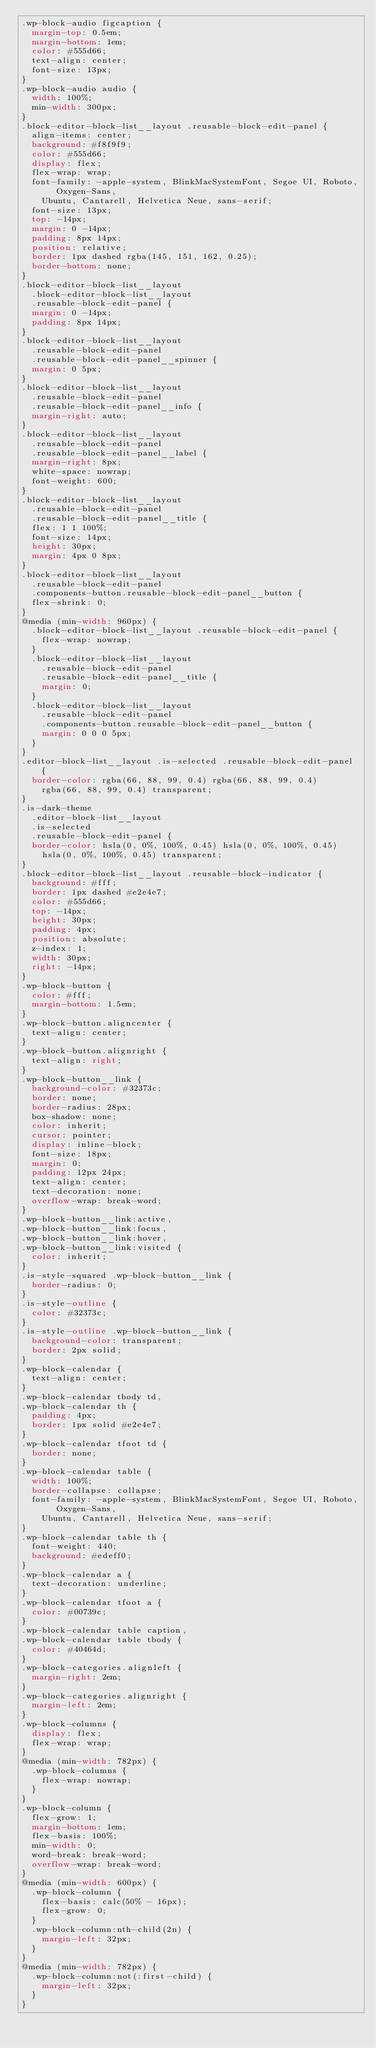Convert code to text. <code><loc_0><loc_0><loc_500><loc_500><_CSS_>.wp-block-audio figcaption {
  margin-top: 0.5em;
  margin-bottom: 1em;
  color: #555d66;
  text-align: center;
  font-size: 13px;
}
.wp-block-audio audio {
  width: 100%;
  min-width: 300px;
}
.block-editor-block-list__layout .reusable-block-edit-panel {
  align-items: center;
  background: #f8f9f9;
  color: #555d66;
  display: flex;
  flex-wrap: wrap;
  font-family: -apple-system, BlinkMacSystemFont, Segoe UI, Roboto, Oxygen-Sans,
    Ubuntu, Cantarell, Helvetica Neue, sans-serif;
  font-size: 13px;
  top: -14px;
  margin: 0 -14px;
  padding: 8px 14px;
  position: relative;
  border: 1px dashed rgba(145, 151, 162, 0.25);
  border-bottom: none;
}
.block-editor-block-list__layout
  .block-editor-block-list__layout
  .reusable-block-edit-panel {
  margin: 0 -14px;
  padding: 8px 14px;
}
.block-editor-block-list__layout
  .reusable-block-edit-panel
  .reusable-block-edit-panel__spinner {
  margin: 0 5px;
}
.block-editor-block-list__layout
  .reusable-block-edit-panel
  .reusable-block-edit-panel__info {
  margin-right: auto;
}
.block-editor-block-list__layout
  .reusable-block-edit-panel
  .reusable-block-edit-panel__label {
  margin-right: 8px;
  white-space: nowrap;
  font-weight: 600;
}
.block-editor-block-list__layout
  .reusable-block-edit-panel
  .reusable-block-edit-panel__title {
  flex: 1 1 100%;
  font-size: 14px;
  height: 30px;
  margin: 4px 0 8px;
}
.block-editor-block-list__layout
  .reusable-block-edit-panel
  .components-button.reusable-block-edit-panel__button {
  flex-shrink: 0;
}
@media (min-width: 960px) {
  .block-editor-block-list__layout .reusable-block-edit-panel {
    flex-wrap: nowrap;
  }
  .block-editor-block-list__layout
    .reusable-block-edit-panel
    .reusable-block-edit-panel__title {
    margin: 0;
  }
  .block-editor-block-list__layout
    .reusable-block-edit-panel
    .components-button.reusable-block-edit-panel__button {
    margin: 0 0 0 5px;
  }
}
.editor-block-list__layout .is-selected .reusable-block-edit-panel {
  border-color: rgba(66, 88, 99, 0.4) rgba(66, 88, 99, 0.4)
    rgba(66, 88, 99, 0.4) transparent;
}
.is-dark-theme
  .editor-block-list__layout
  .is-selected
  .reusable-block-edit-panel {
  border-color: hsla(0, 0%, 100%, 0.45) hsla(0, 0%, 100%, 0.45)
    hsla(0, 0%, 100%, 0.45) transparent;
}
.block-editor-block-list__layout .reusable-block-indicator {
  background: #fff;
  border: 1px dashed #e2e4e7;
  color: #555d66;
  top: -14px;
  height: 30px;
  padding: 4px;
  position: absolute;
  z-index: 1;
  width: 30px;
  right: -14px;
}
.wp-block-button {
  color: #fff;
  margin-bottom: 1.5em;
}
.wp-block-button.aligncenter {
  text-align: center;
}
.wp-block-button.alignright {
  text-align: right;
}
.wp-block-button__link {
  background-color: #32373c;
  border: none;
  border-radius: 28px;
  box-shadow: none;
  color: inherit;
  cursor: pointer;
  display: inline-block;
  font-size: 18px;
  margin: 0;
  padding: 12px 24px;
  text-align: center;
  text-decoration: none;
  overflow-wrap: break-word;
}
.wp-block-button__link:active,
.wp-block-button__link:focus,
.wp-block-button__link:hover,
.wp-block-button__link:visited {
  color: inherit;
}
.is-style-squared .wp-block-button__link {
  border-radius: 0;
}
.is-style-outline {
  color: #32373c;
}
.is-style-outline .wp-block-button__link {
  background-color: transparent;
  border: 2px solid;
}
.wp-block-calendar {
  text-align: center;
}
.wp-block-calendar tbody td,
.wp-block-calendar th {
  padding: 4px;
  border: 1px solid #e2e4e7;
}
.wp-block-calendar tfoot td {
  border: none;
}
.wp-block-calendar table {
  width: 100%;
  border-collapse: collapse;
  font-family: -apple-system, BlinkMacSystemFont, Segoe UI, Roboto, Oxygen-Sans,
    Ubuntu, Cantarell, Helvetica Neue, sans-serif;
}
.wp-block-calendar table th {
  font-weight: 440;
  background: #edeff0;
}
.wp-block-calendar a {
  text-decoration: underline;
}
.wp-block-calendar tfoot a {
  color: #00739c;
}
.wp-block-calendar table caption,
.wp-block-calendar table tbody {
  color: #40464d;
}
.wp-block-categories.alignleft {
  margin-right: 2em;
}
.wp-block-categories.alignright {
  margin-left: 2em;
}
.wp-block-columns {
  display: flex;
  flex-wrap: wrap;
}
@media (min-width: 782px) {
  .wp-block-columns {
    flex-wrap: nowrap;
  }
}
.wp-block-column {
  flex-grow: 1;
  margin-bottom: 1em;
  flex-basis: 100%;
  min-width: 0;
  word-break: break-word;
  overflow-wrap: break-word;
}
@media (min-width: 600px) {
  .wp-block-column {
    flex-basis: calc(50% - 16px);
    flex-grow: 0;
  }
  .wp-block-column:nth-child(2n) {
    margin-left: 32px;
  }
}
@media (min-width: 782px) {
  .wp-block-column:not(:first-child) {
    margin-left: 32px;
  }
}</code> 